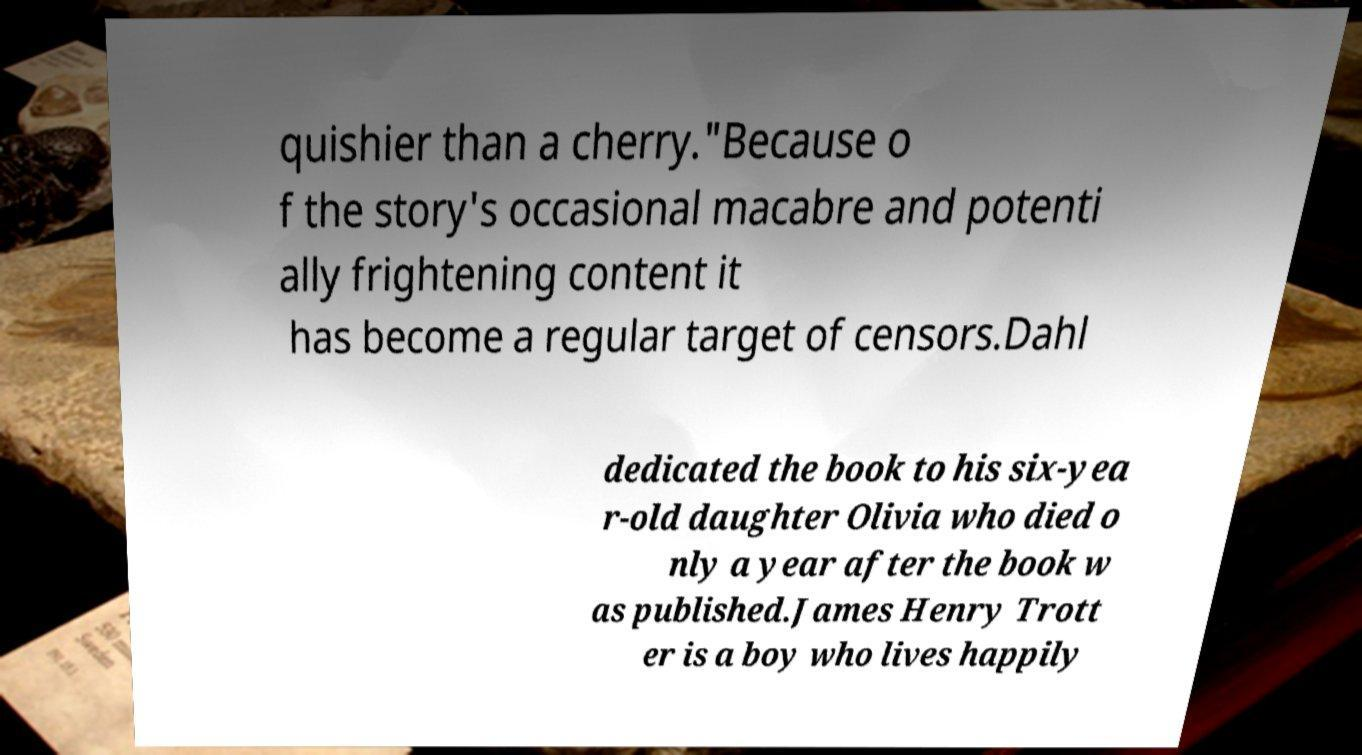Could you extract and type out the text from this image? quishier than a cherry."Because o f the story's occasional macabre and potenti ally frightening content it has become a regular target of censors.Dahl dedicated the book to his six-yea r-old daughter Olivia who died o nly a year after the book w as published.James Henry Trott er is a boy who lives happily 